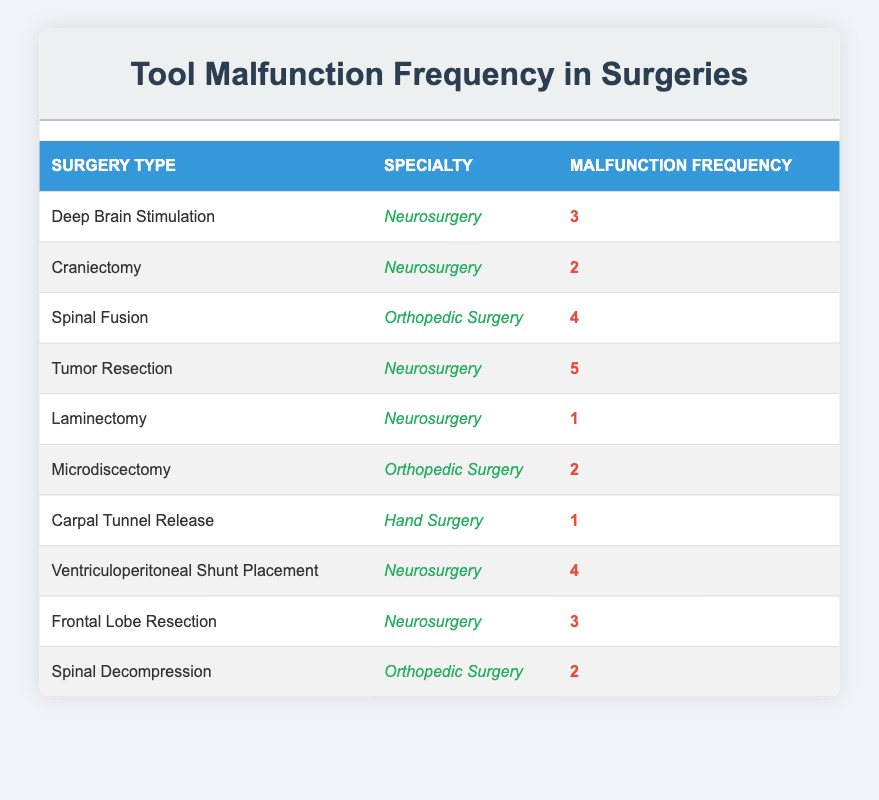What is the highest malfunction frequency recorded in neurosurgery? The neurosurgery category includes several surgery types. By examining the frequency values: Deep Brain Stimulation (3), Craniectomy (2), Tumor Resection (5), Laminectomy (1), Ventriculoperitoneal Shunt Placement (4), and Frontal Lobe Resection (3), the highest frequency is identified at Tumor Resection with a frequency of 5.
Answer: 5 How many different types of surgeries have a malfunction frequency of 2? Looking at the table, the surgeries with a frequency of 2 are: Craniectomy (Neurosurgery), Microdiscectomy (Orthopedic Surgery), and Spinal Decompression (Orthopedic Surgery). Thus, there are 3 different types.
Answer: 3 Is there at least one surgery in hand surgery with a malfunction frequency greater than 1? The only surgery listed in Hand Surgery is Carpal Tunnel Release, which has a malfunction frequency of 1. Therefore, there are no surgeries in Hand Surgery with a frequency greater than 1.
Answer: No What is the total malfunction frequency for orthopedic surgeries? The orthopedic surgeries and their frequencies are: Spinal Fusion (4), Microdiscectomy (2), and Spinal Decompression (2). Adding them gives us 4 + 2 + 2 = 8.
Answer: 8 Which specialty has the highest total malfunction frequency across its surgeries? For Neurosurgery: 3 (Deep Brain Stimulation) + 2 (Craniectomy) + 5 (Tumor Resection) + 1 (Laminectomy) + 4 (Ventriculoperitoneal Shunt Placement) + 3 (Frontal Lobe Resection) = 18. For Orthopedic Surgery: 4 (Spinal Fusion) + 2 (Microdiscectomy) + 2 (Spinal Decompression) = 8. Hand Surgery has a total of 1 (Carpal Tunnel Release). Thus, Neurosurgery has the highest frequency totaling 18.
Answer: Neurosurgery How many surgeries report a malfunction frequency of 1? The surgeries with a frequency of 1 are Laminectomy (Neurosurgery) and Carpal Tunnel Release (Hand Surgery). Therefore, there are 2 surgeries in total.
Answer: 2 